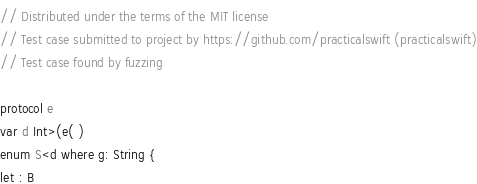<code> <loc_0><loc_0><loc_500><loc_500><_Swift_>// Distributed under the terms of the MIT license
// Test case submitted to project by https://github.com/practicalswift (practicalswift)
// Test case found by fuzzing

protocol e
var d Int>(e( )
enum S<d where g: String {
let : B
</code> 